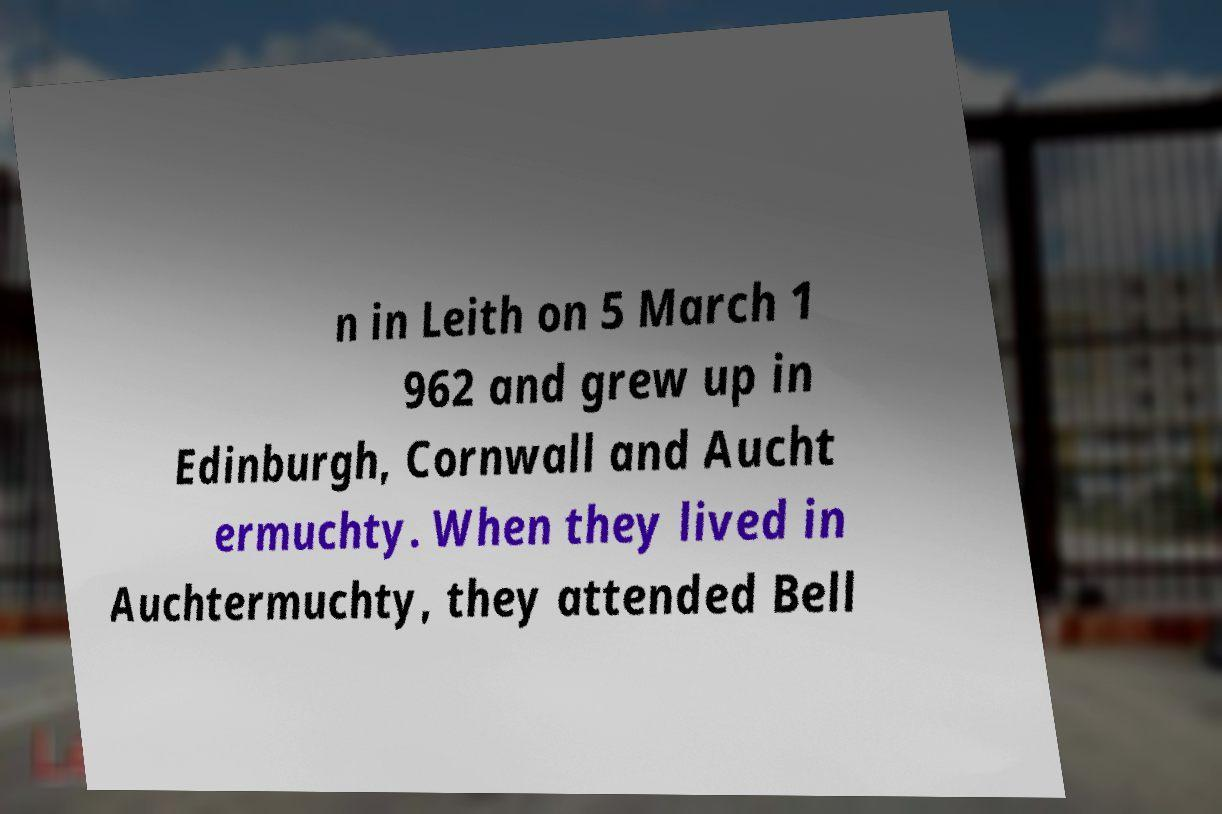Can you read and provide the text displayed in the image?This photo seems to have some interesting text. Can you extract and type it out for me? n in Leith on 5 March 1 962 and grew up in Edinburgh, Cornwall and Aucht ermuchty. When they lived in Auchtermuchty, they attended Bell 